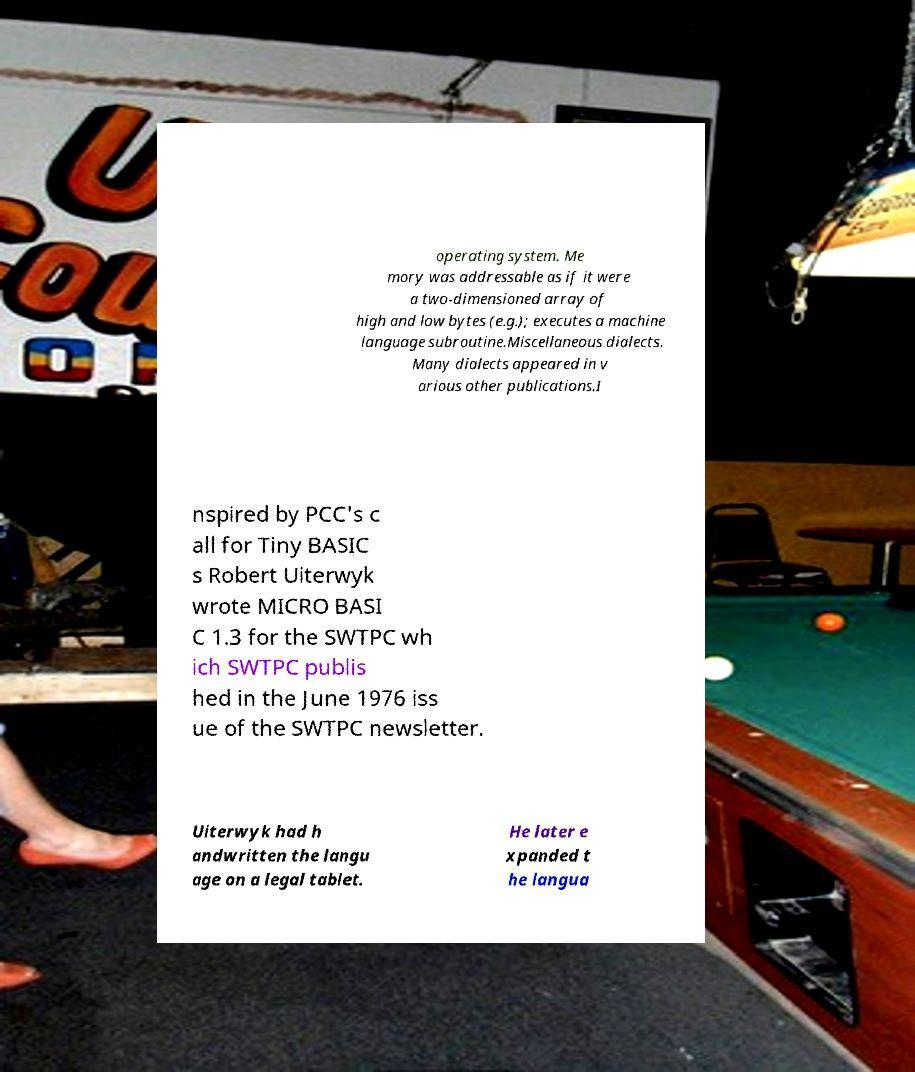Could you extract and type out the text from this image? operating system. Me mory was addressable as if it were a two-dimensioned array of high and low bytes (e.g.); executes a machine language subroutine.Miscellaneous dialects. Many dialects appeared in v arious other publications.I nspired by PCC's c all for Tiny BASIC s Robert Uiterwyk wrote MICRO BASI C 1.3 for the SWTPC wh ich SWTPC publis hed in the June 1976 iss ue of the SWTPC newsletter. Uiterwyk had h andwritten the langu age on a legal tablet. He later e xpanded t he langua 